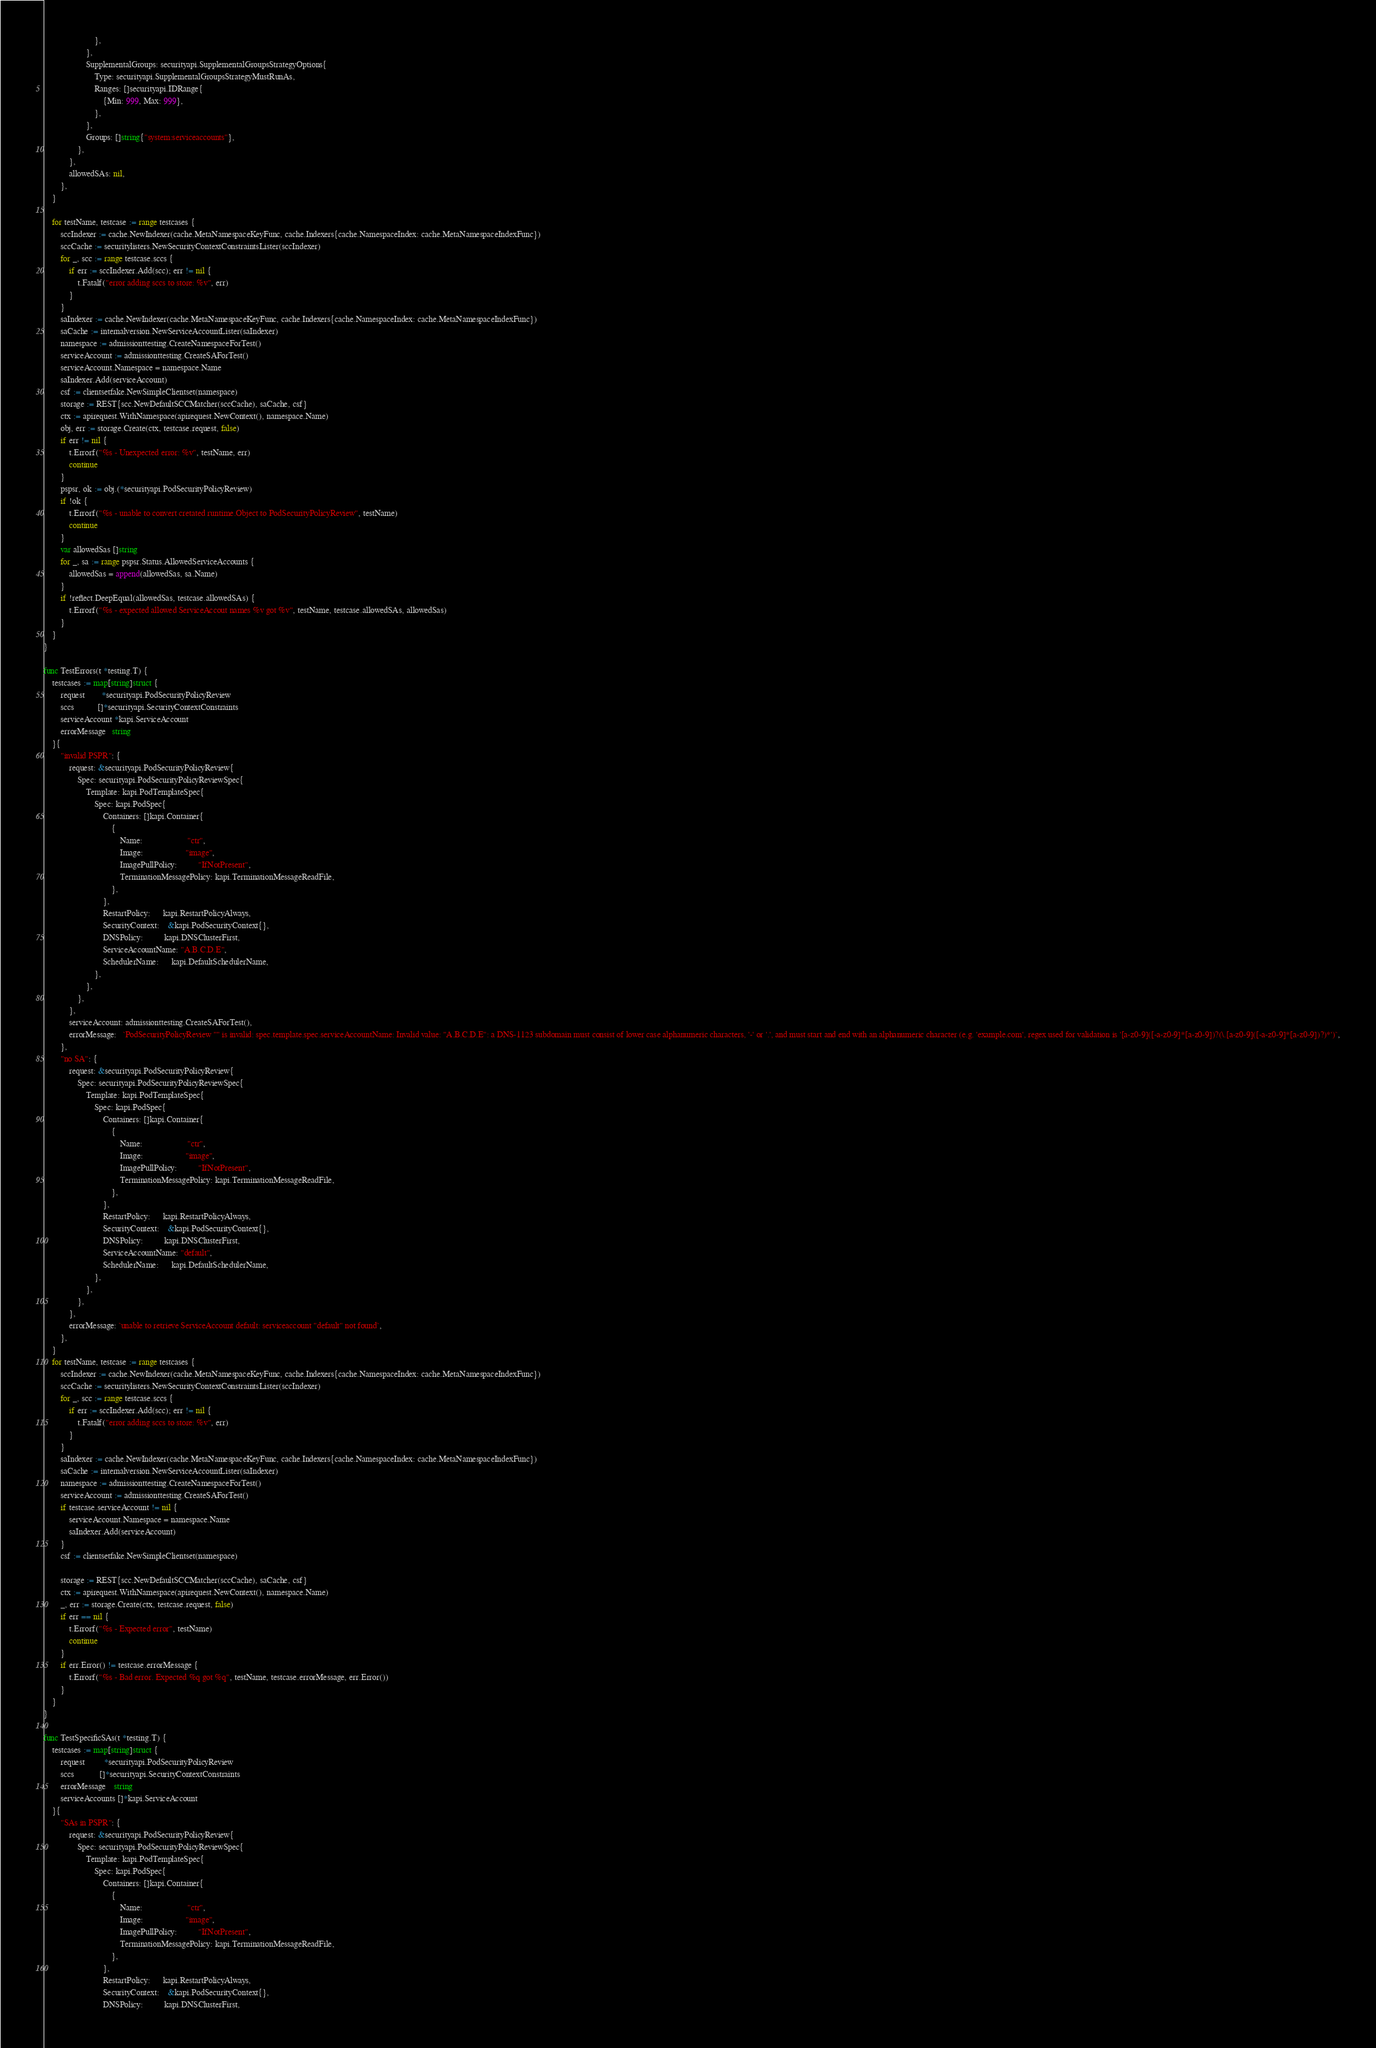<code> <loc_0><loc_0><loc_500><loc_500><_Go_>						},
					},
					SupplementalGroups: securityapi.SupplementalGroupsStrategyOptions{
						Type: securityapi.SupplementalGroupsStrategyMustRunAs,
						Ranges: []securityapi.IDRange{
							{Min: 999, Max: 999},
						},
					},
					Groups: []string{"system:serviceaccounts"},
				},
			},
			allowedSAs: nil,
		},
	}

	for testName, testcase := range testcases {
		sccIndexer := cache.NewIndexer(cache.MetaNamespaceKeyFunc, cache.Indexers{cache.NamespaceIndex: cache.MetaNamespaceIndexFunc})
		sccCache := securitylisters.NewSecurityContextConstraintsLister(sccIndexer)
		for _, scc := range testcase.sccs {
			if err := sccIndexer.Add(scc); err != nil {
				t.Fatalf("error adding sccs to store: %v", err)
			}
		}
		saIndexer := cache.NewIndexer(cache.MetaNamespaceKeyFunc, cache.Indexers{cache.NamespaceIndex: cache.MetaNamespaceIndexFunc})
		saCache := internalversion.NewServiceAccountLister(saIndexer)
		namespace := admissionttesting.CreateNamespaceForTest()
		serviceAccount := admissionttesting.CreateSAForTest()
		serviceAccount.Namespace = namespace.Name
		saIndexer.Add(serviceAccount)
		csf := clientsetfake.NewSimpleClientset(namespace)
		storage := REST{scc.NewDefaultSCCMatcher(sccCache), saCache, csf}
		ctx := apirequest.WithNamespace(apirequest.NewContext(), namespace.Name)
		obj, err := storage.Create(ctx, testcase.request, false)
		if err != nil {
			t.Errorf("%s - Unexpected error: %v", testName, err)
			continue
		}
		pspsr, ok := obj.(*securityapi.PodSecurityPolicyReview)
		if !ok {
			t.Errorf("%s - unable to convert cretated runtime.Object to PodSecurityPolicyReview", testName)
			continue
		}
		var allowedSas []string
		for _, sa := range pspsr.Status.AllowedServiceAccounts {
			allowedSas = append(allowedSas, sa.Name)
		}
		if !reflect.DeepEqual(allowedSas, testcase.allowedSAs) {
			t.Errorf("%s - expected allowed ServiceAccout names %v got %v", testName, testcase.allowedSAs, allowedSas)
		}
	}
}

func TestErrors(t *testing.T) {
	testcases := map[string]struct {
		request        *securityapi.PodSecurityPolicyReview
		sccs           []*securityapi.SecurityContextConstraints
		serviceAccount *kapi.ServiceAccount
		errorMessage   string
	}{
		"invalid PSPR": {
			request: &securityapi.PodSecurityPolicyReview{
				Spec: securityapi.PodSecurityPolicyReviewSpec{
					Template: kapi.PodTemplateSpec{
						Spec: kapi.PodSpec{
							Containers: []kapi.Container{
								{
									Name:                     "ctr",
									Image:                    "image",
									ImagePullPolicy:          "IfNotPresent",
									TerminationMessagePolicy: kapi.TerminationMessageReadFile,
								},
							},
							RestartPolicy:      kapi.RestartPolicyAlways,
							SecurityContext:    &kapi.PodSecurityContext{},
							DNSPolicy:          kapi.DNSClusterFirst,
							ServiceAccountName: "A.B.C.D.E",
							SchedulerName:      kapi.DefaultSchedulerName,
						},
					},
				},
			},
			serviceAccount: admissionttesting.CreateSAForTest(),
			errorMessage:   `PodSecurityPolicyReview "" is invalid: spec.template.spec.serviceAccountName: Invalid value: "A.B.C.D.E": a DNS-1123 subdomain must consist of lower case alphanumeric characters, '-' or '.', and must start and end with an alphanumeric character (e.g. 'example.com', regex used for validation is '[a-z0-9]([-a-z0-9]*[a-z0-9])?(\.[a-z0-9]([-a-z0-9]*[a-z0-9])?)*')`,
		},
		"no SA": {
			request: &securityapi.PodSecurityPolicyReview{
				Spec: securityapi.PodSecurityPolicyReviewSpec{
					Template: kapi.PodTemplateSpec{
						Spec: kapi.PodSpec{
							Containers: []kapi.Container{
								{
									Name:                     "ctr",
									Image:                    "image",
									ImagePullPolicy:          "IfNotPresent",
									TerminationMessagePolicy: kapi.TerminationMessageReadFile,
								},
							},
							RestartPolicy:      kapi.RestartPolicyAlways,
							SecurityContext:    &kapi.PodSecurityContext{},
							DNSPolicy:          kapi.DNSClusterFirst,
							ServiceAccountName: "default",
							SchedulerName:      kapi.DefaultSchedulerName,
						},
					},
				},
			},
			errorMessage: `unable to retrieve ServiceAccount default: serviceaccount "default" not found`,
		},
	}
	for testName, testcase := range testcases {
		sccIndexer := cache.NewIndexer(cache.MetaNamespaceKeyFunc, cache.Indexers{cache.NamespaceIndex: cache.MetaNamespaceIndexFunc})
		sccCache := securitylisters.NewSecurityContextConstraintsLister(sccIndexer)
		for _, scc := range testcase.sccs {
			if err := sccIndexer.Add(scc); err != nil {
				t.Fatalf("error adding sccs to store: %v", err)
			}
		}
		saIndexer := cache.NewIndexer(cache.MetaNamespaceKeyFunc, cache.Indexers{cache.NamespaceIndex: cache.MetaNamespaceIndexFunc})
		saCache := internalversion.NewServiceAccountLister(saIndexer)
		namespace := admissionttesting.CreateNamespaceForTest()
		serviceAccount := admissionttesting.CreateSAForTest()
		if testcase.serviceAccount != nil {
			serviceAccount.Namespace = namespace.Name
			saIndexer.Add(serviceAccount)
		}
		csf := clientsetfake.NewSimpleClientset(namespace)

		storage := REST{scc.NewDefaultSCCMatcher(sccCache), saCache, csf}
		ctx := apirequest.WithNamespace(apirequest.NewContext(), namespace.Name)
		_, err := storage.Create(ctx, testcase.request, false)
		if err == nil {
			t.Errorf("%s - Expected error", testName)
			continue
		}
		if err.Error() != testcase.errorMessage {
			t.Errorf("%s - Bad error. Expected %q got %q", testName, testcase.errorMessage, err.Error())
		}
	}
}

func TestSpecificSAs(t *testing.T) {
	testcases := map[string]struct {
		request         *securityapi.PodSecurityPolicyReview
		sccs            []*securityapi.SecurityContextConstraints
		errorMessage    string
		serviceAccounts []*kapi.ServiceAccount
	}{
		"SAs in PSPR": {
			request: &securityapi.PodSecurityPolicyReview{
				Spec: securityapi.PodSecurityPolicyReviewSpec{
					Template: kapi.PodTemplateSpec{
						Spec: kapi.PodSpec{
							Containers: []kapi.Container{
								{
									Name:                     "ctr",
									Image:                    "image",
									ImagePullPolicy:          "IfNotPresent",
									TerminationMessagePolicy: kapi.TerminationMessageReadFile,
								},
							},
							RestartPolicy:      kapi.RestartPolicyAlways,
							SecurityContext:    &kapi.PodSecurityContext{},
							DNSPolicy:          kapi.DNSClusterFirst,</code> 